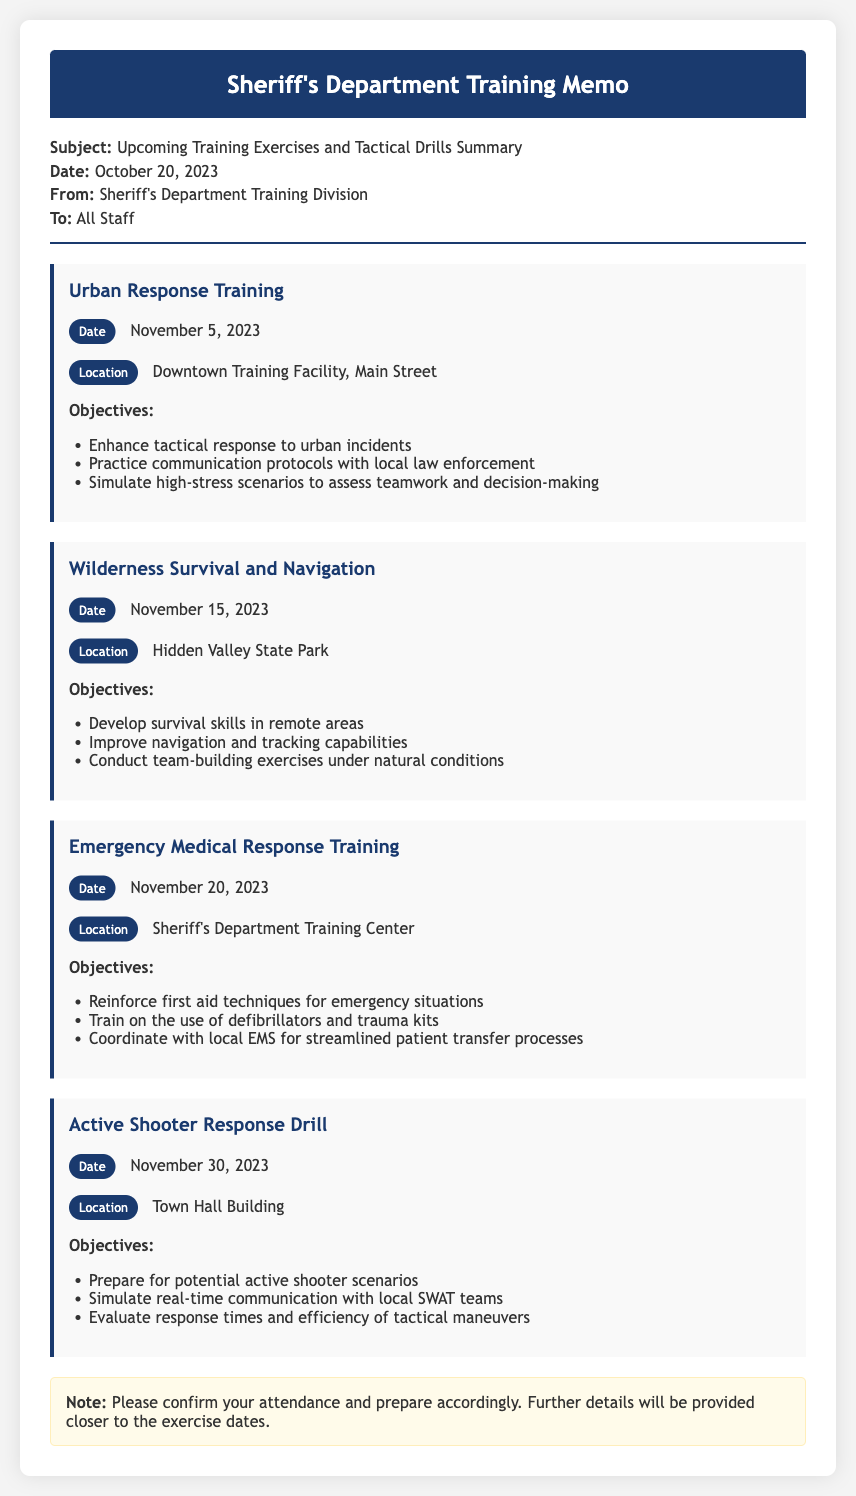what is the date of the Urban Response Training? The date for the Urban Response Training is mentioned in the document.
Answer: November 5, 2023 where is the Wilderness Survival and Navigation training taking place? The location for the Wilderness Survival and Navigation training is explicitly stated in the document.
Answer: Hidden Valley State Park what are the objectives of the Emergency Medical Response Training? The objectives for the Emergency Medical Response Training are listed as bullet points in the document.
Answer: Reinforce first aid techniques for emergency situations, train on the use of defibrillators and trauma kits, coordinate with local EMS for streamlined patient transfer processes how many training exercises are outlined in the memo? The memo lists the total number of training exercises provided in its content.
Answer: Four when is the Active Shooter Response Drill scheduled? The date for the Active Shooter Response Drill is clearly provided in the memo.
Answer: November 30, 2023 who is the memo addressed to? The memo indicates the recipient of the communication.
Answer: All Staff what is a critical aspect of the Urban Response Training objectives? The objectives for Urban Response Training include specific key elements aimed at enhancing skills.
Answer: Enhance tactical response to urban incidents what should attendees do ahead of the training exercises? The memo includes a note with instructions for staff regarding preparations.
Answer: Confirm your attendance and prepare accordingly 